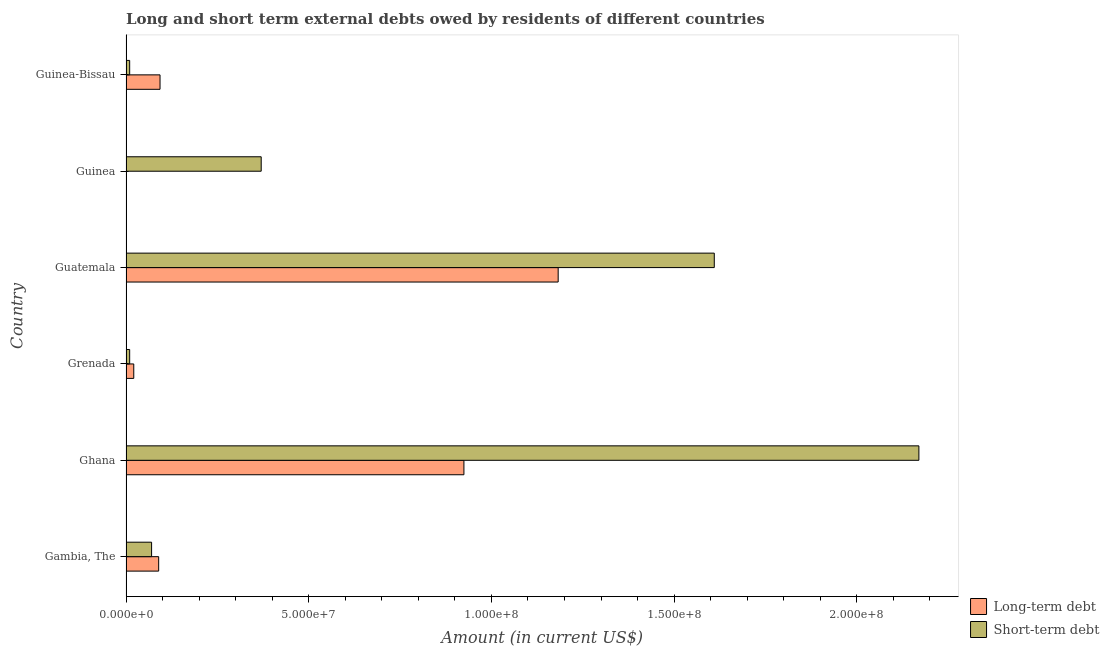How many different coloured bars are there?
Your response must be concise. 2. Are the number of bars on each tick of the Y-axis equal?
Provide a succinct answer. No. How many bars are there on the 6th tick from the top?
Ensure brevity in your answer.  2. What is the label of the 3rd group of bars from the top?
Ensure brevity in your answer.  Guatemala. What is the short-term debts owed by residents in Ghana?
Give a very brief answer. 2.17e+08. Across all countries, what is the maximum long-term debts owed by residents?
Offer a terse response. 1.18e+08. Across all countries, what is the minimum short-term debts owed by residents?
Your answer should be very brief. 1.00e+06. In which country was the short-term debts owed by residents maximum?
Make the answer very short. Ghana. What is the total long-term debts owed by residents in the graph?
Offer a very short reply. 2.31e+08. What is the difference between the long-term debts owed by residents in Gambia, The and that in Grenada?
Your response must be concise. 6.82e+06. What is the difference between the long-term debts owed by residents in Grenada and the short-term debts owed by residents in Ghana?
Your answer should be very brief. -2.15e+08. What is the average long-term debts owed by residents per country?
Give a very brief answer. 3.85e+07. What is the difference between the long-term debts owed by residents and short-term debts owed by residents in Guinea-Bissau?
Your answer should be very brief. 8.31e+06. In how many countries, is the long-term debts owed by residents greater than 200000000 US$?
Ensure brevity in your answer.  0. What is the ratio of the short-term debts owed by residents in Gambia, The to that in Guatemala?
Offer a very short reply. 0.04. Is the difference between the short-term debts owed by residents in Ghana and Guinea-Bissau greater than the difference between the long-term debts owed by residents in Ghana and Guinea-Bissau?
Provide a short and direct response. Yes. What is the difference between the highest and the second highest long-term debts owed by residents?
Your answer should be very brief. 2.58e+07. What is the difference between the highest and the lowest long-term debts owed by residents?
Your answer should be very brief. 1.18e+08. In how many countries, is the short-term debts owed by residents greater than the average short-term debts owed by residents taken over all countries?
Offer a very short reply. 2. How many countries are there in the graph?
Provide a short and direct response. 6. Are the values on the major ticks of X-axis written in scientific E-notation?
Give a very brief answer. Yes. Does the graph contain any zero values?
Give a very brief answer. Yes. How are the legend labels stacked?
Keep it short and to the point. Vertical. What is the title of the graph?
Provide a short and direct response. Long and short term external debts owed by residents of different countries. What is the label or title of the X-axis?
Provide a succinct answer. Amount (in current US$). What is the Amount (in current US$) in Long-term debt in Gambia, The?
Your answer should be very brief. 8.94e+06. What is the Amount (in current US$) in Long-term debt in Ghana?
Your answer should be very brief. 9.25e+07. What is the Amount (in current US$) of Short-term debt in Ghana?
Your answer should be very brief. 2.17e+08. What is the Amount (in current US$) in Long-term debt in Grenada?
Offer a terse response. 2.12e+06. What is the Amount (in current US$) in Long-term debt in Guatemala?
Ensure brevity in your answer.  1.18e+08. What is the Amount (in current US$) of Short-term debt in Guatemala?
Provide a succinct answer. 1.61e+08. What is the Amount (in current US$) of Short-term debt in Guinea?
Make the answer very short. 3.70e+07. What is the Amount (in current US$) in Long-term debt in Guinea-Bissau?
Give a very brief answer. 9.31e+06. Across all countries, what is the maximum Amount (in current US$) of Long-term debt?
Your response must be concise. 1.18e+08. Across all countries, what is the maximum Amount (in current US$) in Short-term debt?
Your response must be concise. 2.17e+08. Across all countries, what is the minimum Amount (in current US$) of Long-term debt?
Make the answer very short. 0. What is the total Amount (in current US$) of Long-term debt in the graph?
Give a very brief answer. 2.31e+08. What is the total Amount (in current US$) in Short-term debt in the graph?
Your answer should be compact. 4.24e+08. What is the difference between the Amount (in current US$) of Long-term debt in Gambia, The and that in Ghana?
Your response must be concise. -8.35e+07. What is the difference between the Amount (in current US$) of Short-term debt in Gambia, The and that in Ghana?
Your answer should be very brief. -2.10e+08. What is the difference between the Amount (in current US$) of Long-term debt in Gambia, The and that in Grenada?
Your answer should be very brief. 6.82e+06. What is the difference between the Amount (in current US$) of Short-term debt in Gambia, The and that in Grenada?
Your response must be concise. 6.00e+06. What is the difference between the Amount (in current US$) of Long-term debt in Gambia, The and that in Guatemala?
Your answer should be very brief. -1.09e+08. What is the difference between the Amount (in current US$) of Short-term debt in Gambia, The and that in Guatemala?
Your answer should be very brief. -1.54e+08. What is the difference between the Amount (in current US$) of Short-term debt in Gambia, The and that in Guinea?
Offer a very short reply. -3.00e+07. What is the difference between the Amount (in current US$) of Long-term debt in Gambia, The and that in Guinea-Bissau?
Your response must be concise. -3.73e+05. What is the difference between the Amount (in current US$) in Short-term debt in Gambia, The and that in Guinea-Bissau?
Offer a terse response. 6.00e+06. What is the difference between the Amount (in current US$) of Long-term debt in Ghana and that in Grenada?
Offer a terse response. 9.04e+07. What is the difference between the Amount (in current US$) in Short-term debt in Ghana and that in Grenada?
Your answer should be very brief. 2.16e+08. What is the difference between the Amount (in current US$) in Long-term debt in Ghana and that in Guatemala?
Provide a succinct answer. -2.58e+07. What is the difference between the Amount (in current US$) in Short-term debt in Ghana and that in Guatemala?
Your answer should be compact. 5.60e+07. What is the difference between the Amount (in current US$) in Short-term debt in Ghana and that in Guinea?
Your answer should be compact. 1.80e+08. What is the difference between the Amount (in current US$) of Long-term debt in Ghana and that in Guinea-Bissau?
Offer a terse response. 8.32e+07. What is the difference between the Amount (in current US$) in Short-term debt in Ghana and that in Guinea-Bissau?
Offer a very short reply. 2.16e+08. What is the difference between the Amount (in current US$) in Long-term debt in Grenada and that in Guatemala?
Keep it short and to the point. -1.16e+08. What is the difference between the Amount (in current US$) in Short-term debt in Grenada and that in Guatemala?
Provide a short and direct response. -1.60e+08. What is the difference between the Amount (in current US$) in Short-term debt in Grenada and that in Guinea?
Provide a succinct answer. -3.60e+07. What is the difference between the Amount (in current US$) of Long-term debt in Grenada and that in Guinea-Bissau?
Your answer should be compact. -7.19e+06. What is the difference between the Amount (in current US$) in Short-term debt in Guatemala and that in Guinea?
Provide a short and direct response. 1.24e+08. What is the difference between the Amount (in current US$) of Long-term debt in Guatemala and that in Guinea-Bissau?
Offer a very short reply. 1.09e+08. What is the difference between the Amount (in current US$) in Short-term debt in Guatemala and that in Guinea-Bissau?
Your answer should be compact. 1.60e+08. What is the difference between the Amount (in current US$) in Short-term debt in Guinea and that in Guinea-Bissau?
Give a very brief answer. 3.60e+07. What is the difference between the Amount (in current US$) of Long-term debt in Gambia, The and the Amount (in current US$) of Short-term debt in Ghana?
Offer a very short reply. -2.08e+08. What is the difference between the Amount (in current US$) in Long-term debt in Gambia, The and the Amount (in current US$) in Short-term debt in Grenada?
Provide a short and direct response. 7.94e+06. What is the difference between the Amount (in current US$) in Long-term debt in Gambia, The and the Amount (in current US$) in Short-term debt in Guatemala?
Ensure brevity in your answer.  -1.52e+08. What is the difference between the Amount (in current US$) of Long-term debt in Gambia, The and the Amount (in current US$) of Short-term debt in Guinea?
Your answer should be very brief. -2.81e+07. What is the difference between the Amount (in current US$) in Long-term debt in Gambia, The and the Amount (in current US$) in Short-term debt in Guinea-Bissau?
Offer a terse response. 7.94e+06. What is the difference between the Amount (in current US$) in Long-term debt in Ghana and the Amount (in current US$) in Short-term debt in Grenada?
Your answer should be compact. 9.15e+07. What is the difference between the Amount (in current US$) of Long-term debt in Ghana and the Amount (in current US$) of Short-term debt in Guatemala?
Ensure brevity in your answer.  -6.85e+07. What is the difference between the Amount (in current US$) of Long-term debt in Ghana and the Amount (in current US$) of Short-term debt in Guinea?
Your response must be concise. 5.55e+07. What is the difference between the Amount (in current US$) of Long-term debt in Ghana and the Amount (in current US$) of Short-term debt in Guinea-Bissau?
Keep it short and to the point. 9.15e+07. What is the difference between the Amount (in current US$) in Long-term debt in Grenada and the Amount (in current US$) in Short-term debt in Guatemala?
Provide a succinct answer. -1.59e+08. What is the difference between the Amount (in current US$) of Long-term debt in Grenada and the Amount (in current US$) of Short-term debt in Guinea?
Keep it short and to the point. -3.49e+07. What is the difference between the Amount (in current US$) in Long-term debt in Grenada and the Amount (in current US$) in Short-term debt in Guinea-Bissau?
Offer a terse response. 1.12e+06. What is the difference between the Amount (in current US$) of Long-term debt in Guatemala and the Amount (in current US$) of Short-term debt in Guinea?
Your response must be concise. 8.13e+07. What is the difference between the Amount (in current US$) of Long-term debt in Guatemala and the Amount (in current US$) of Short-term debt in Guinea-Bissau?
Keep it short and to the point. 1.17e+08. What is the average Amount (in current US$) of Long-term debt per country?
Offer a very short reply. 3.85e+07. What is the average Amount (in current US$) in Short-term debt per country?
Provide a succinct answer. 7.07e+07. What is the difference between the Amount (in current US$) in Long-term debt and Amount (in current US$) in Short-term debt in Gambia, The?
Your answer should be very brief. 1.94e+06. What is the difference between the Amount (in current US$) in Long-term debt and Amount (in current US$) in Short-term debt in Ghana?
Offer a terse response. -1.25e+08. What is the difference between the Amount (in current US$) of Long-term debt and Amount (in current US$) of Short-term debt in Grenada?
Provide a succinct answer. 1.12e+06. What is the difference between the Amount (in current US$) in Long-term debt and Amount (in current US$) in Short-term debt in Guatemala?
Your response must be concise. -4.27e+07. What is the difference between the Amount (in current US$) in Long-term debt and Amount (in current US$) in Short-term debt in Guinea-Bissau?
Your answer should be compact. 8.31e+06. What is the ratio of the Amount (in current US$) in Long-term debt in Gambia, The to that in Ghana?
Your answer should be compact. 0.1. What is the ratio of the Amount (in current US$) of Short-term debt in Gambia, The to that in Ghana?
Ensure brevity in your answer.  0.03. What is the ratio of the Amount (in current US$) of Long-term debt in Gambia, The to that in Grenada?
Give a very brief answer. 4.22. What is the ratio of the Amount (in current US$) of Long-term debt in Gambia, The to that in Guatemala?
Provide a short and direct response. 0.08. What is the ratio of the Amount (in current US$) in Short-term debt in Gambia, The to that in Guatemala?
Keep it short and to the point. 0.04. What is the ratio of the Amount (in current US$) in Short-term debt in Gambia, The to that in Guinea?
Your answer should be compact. 0.19. What is the ratio of the Amount (in current US$) of Long-term debt in Gambia, The to that in Guinea-Bissau?
Provide a succinct answer. 0.96. What is the ratio of the Amount (in current US$) of Short-term debt in Gambia, The to that in Guinea-Bissau?
Provide a succinct answer. 7. What is the ratio of the Amount (in current US$) in Long-term debt in Ghana to that in Grenada?
Your response must be concise. 43.62. What is the ratio of the Amount (in current US$) of Short-term debt in Ghana to that in Grenada?
Make the answer very short. 217. What is the ratio of the Amount (in current US$) of Long-term debt in Ghana to that in Guatemala?
Give a very brief answer. 0.78. What is the ratio of the Amount (in current US$) of Short-term debt in Ghana to that in Guatemala?
Your answer should be compact. 1.35. What is the ratio of the Amount (in current US$) of Short-term debt in Ghana to that in Guinea?
Provide a short and direct response. 5.86. What is the ratio of the Amount (in current US$) of Long-term debt in Ghana to that in Guinea-Bissau?
Keep it short and to the point. 9.93. What is the ratio of the Amount (in current US$) in Short-term debt in Ghana to that in Guinea-Bissau?
Offer a very short reply. 217. What is the ratio of the Amount (in current US$) in Long-term debt in Grenada to that in Guatemala?
Give a very brief answer. 0.02. What is the ratio of the Amount (in current US$) in Short-term debt in Grenada to that in Guatemala?
Provide a succinct answer. 0.01. What is the ratio of the Amount (in current US$) of Short-term debt in Grenada to that in Guinea?
Provide a succinct answer. 0.03. What is the ratio of the Amount (in current US$) in Long-term debt in Grenada to that in Guinea-Bissau?
Provide a short and direct response. 0.23. What is the ratio of the Amount (in current US$) of Short-term debt in Grenada to that in Guinea-Bissau?
Your answer should be compact. 1. What is the ratio of the Amount (in current US$) of Short-term debt in Guatemala to that in Guinea?
Give a very brief answer. 4.35. What is the ratio of the Amount (in current US$) in Long-term debt in Guatemala to that in Guinea-Bissau?
Provide a succinct answer. 12.7. What is the ratio of the Amount (in current US$) in Short-term debt in Guatemala to that in Guinea-Bissau?
Make the answer very short. 161. What is the difference between the highest and the second highest Amount (in current US$) of Long-term debt?
Your response must be concise. 2.58e+07. What is the difference between the highest and the second highest Amount (in current US$) of Short-term debt?
Offer a terse response. 5.60e+07. What is the difference between the highest and the lowest Amount (in current US$) in Long-term debt?
Give a very brief answer. 1.18e+08. What is the difference between the highest and the lowest Amount (in current US$) of Short-term debt?
Offer a very short reply. 2.16e+08. 